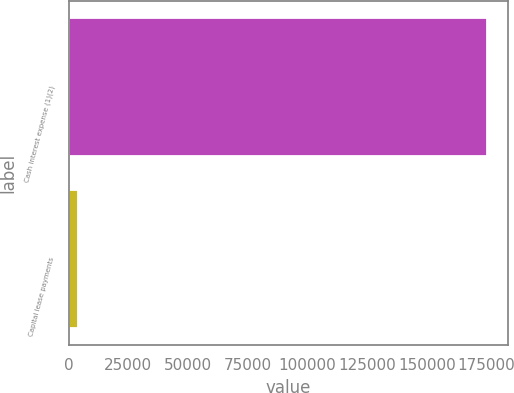Convert chart to OTSL. <chart><loc_0><loc_0><loc_500><loc_500><bar_chart><fcel>Cash interest expense (1)(2)<fcel>Capital lease payments<nl><fcel>175000<fcel>3719<nl></chart> 